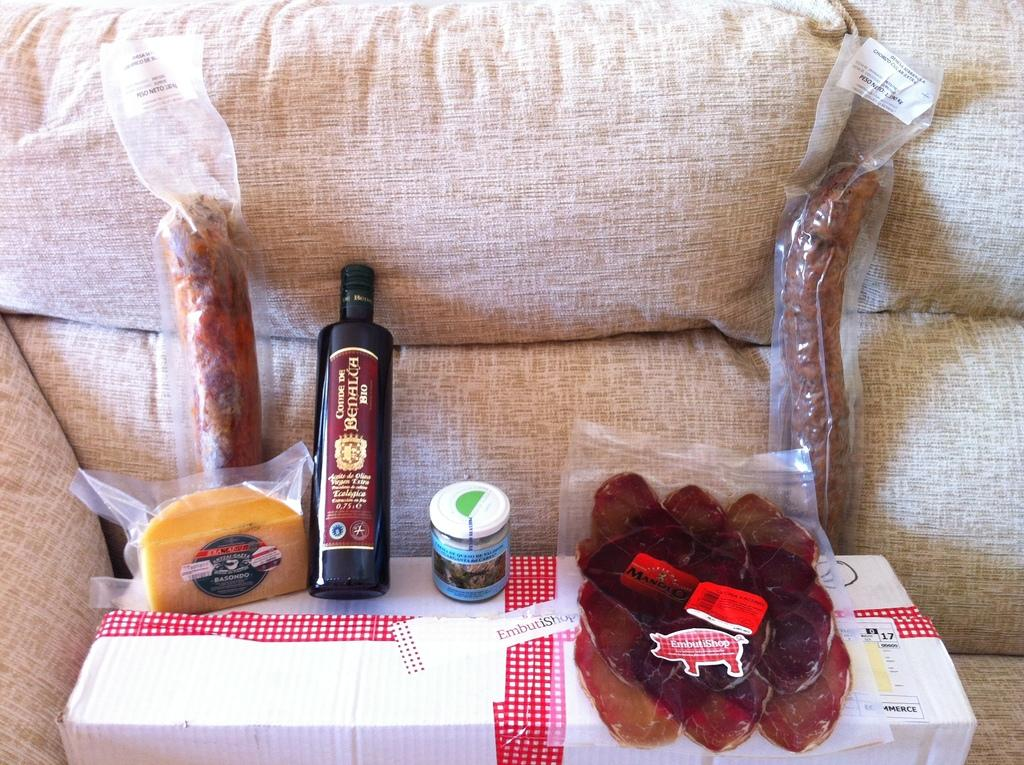What type of objects can be seen in the image? There are food items in the image. Where are the food items placed? The food items are on a white color box. What is the color of the box containing the food items? The box is white. On what is the white color box placed? The white color box is on a sofa. What type of sail can be seen on the sofa in the image? There is no sail present in the image; it features food items on a white color box placed on a sofa. 